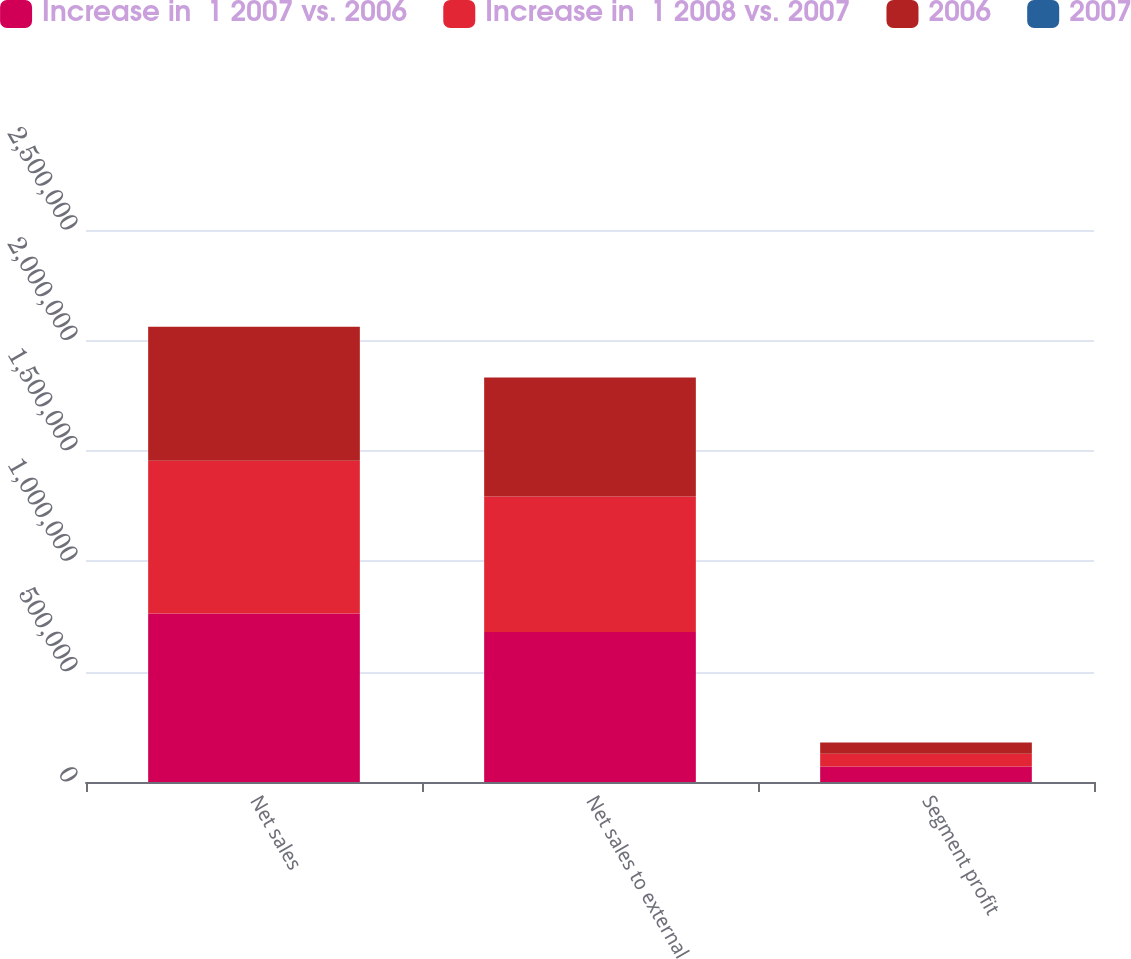Convert chart. <chart><loc_0><loc_0><loc_500><loc_500><stacked_bar_chart><ecel><fcel>Net sales<fcel>Net sales to external<fcel>Segment profit<nl><fcel>Increase in  1 2007 vs. 2006<fcel>762717<fcel>679083<fcel>69837<nl><fcel>Increase in  1 2008 vs. 2007<fcel>691736<fcel>614268<fcel>58497<nl><fcel>2006<fcel>607836<fcel>538953<fcel>50635<nl><fcel>2007<fcel>10<fcel>11<fcel>19<nl></chart> 